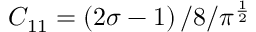Convert formula to latex. <formula><loc_0><loc_0><loc_500><loc_500>C _ { 1 1 } = \left ( 2 \sigma - 1 \right ) / 8 / \pi ^ { \frac { 1 } { 2 } }</formula> 